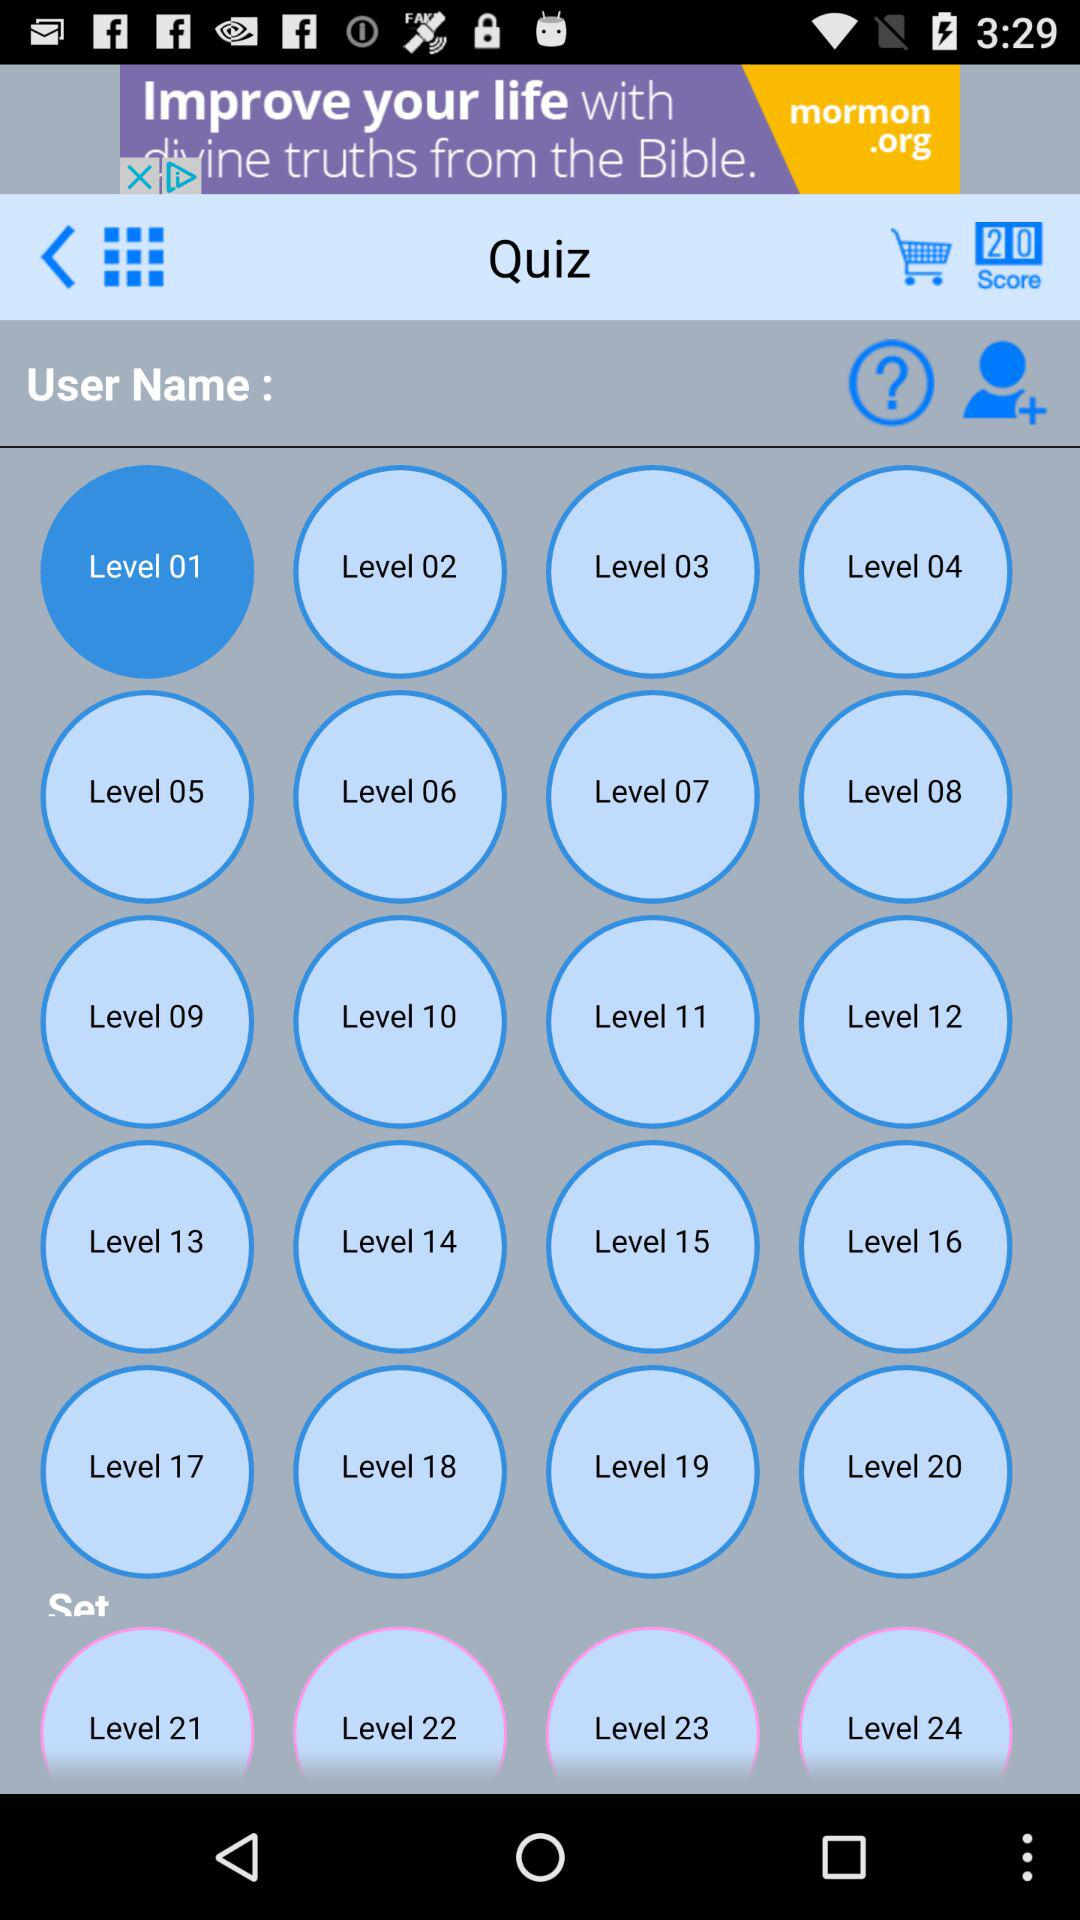How many levels are there in total?
Answer the question using a single word or phrase. 24 